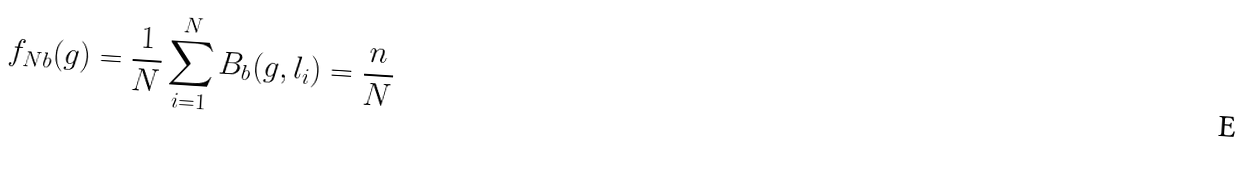<formula> <loc_0><loc_0><loc_500><loc_500>f _ { N b } ( g ) = \frac { 1 } { N } \sum _ { i = 1 } ^ { N } B _ { b } ( g , l _ { i } ) = \frac { n } { N }</formula> 